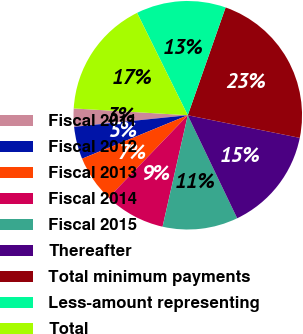<chart> <loc_0><loc_0><loc_500><loc_500><pie_chart><fcel>Fiscal 2011<fcel>Fiscal 2012<fcel>Fiscal 2013<fcel>Fiscal 2014<fcel>Fiscal 2015<fcel>Thereafter<fcel>Total minimum payments<fcel>Less-amount representing<fcel>Total<nl><fcel>2.57%<fcel>4.59%<fcel>6.61%<fcel>8.64%<fcel>10.66%<fcel>14.71%<fcel>22.8%<fcel>12.69%<fcel>16.73%<nl></chart> 